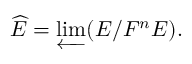Convert formula to latex. <formula><loc_0><loc_0><loc_500><loc_500>{ \widehat { E } } = \varprojlim ( E / F ^ { n } E ) .</formula> 